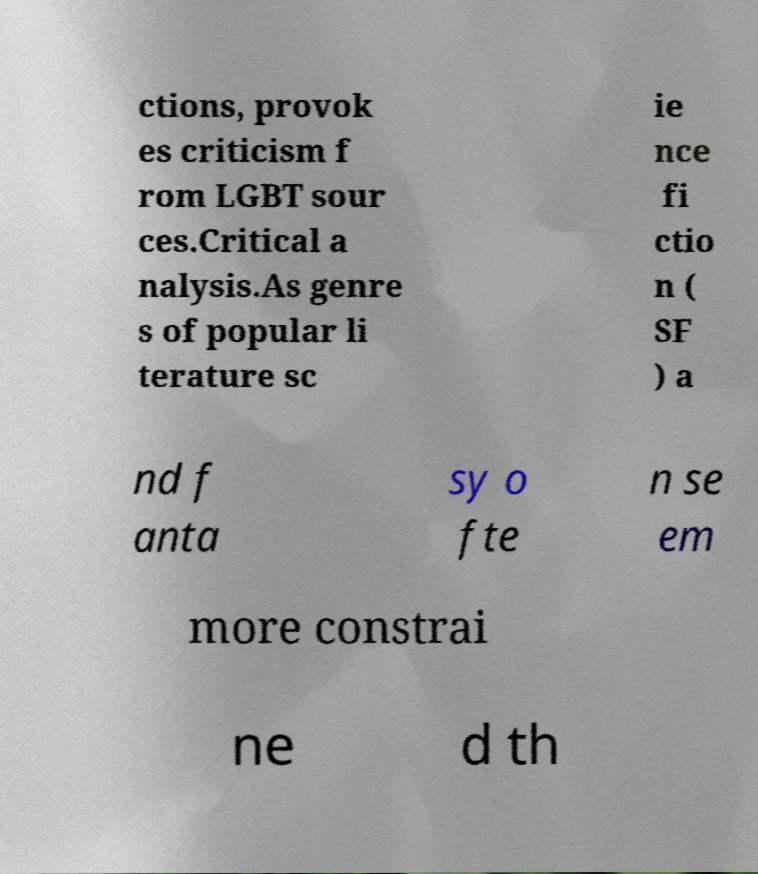Please read and relay the text visible in this image. What does it say? ctions, provok es criticism f rom LGBT sour ces.Critical a nalysis.As genre s of popular li terature sc ie nce fi ctio n ( SF ) a nd f anta sy o fte n se em more constrai ne d th 